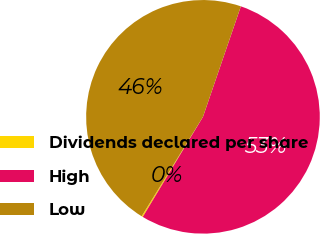<chart> <loc_0><loc_0><loc_500><loc_500><pie_chart><fcel>Dividends declared per share<fcel>High<fcel>Low<nl><fcel>0.17%<fcel>53.36%<fcel>46.47%<nl></chart> 